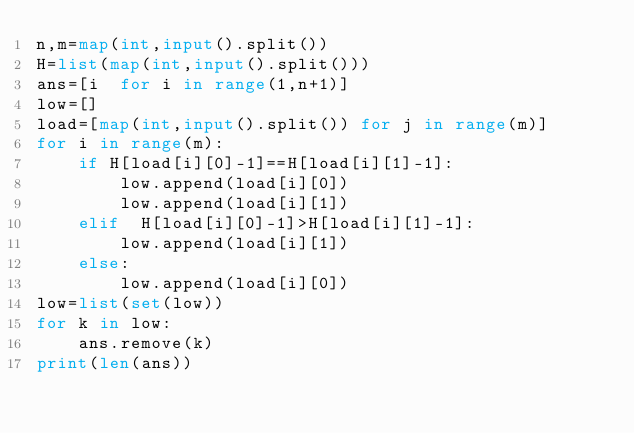<code> <loc_0><loc_0><loc_500><loc_500><_Python_>n,m=map(int,input().split())
H=list(map(int,input().split()))
ans=[i  for i in range(1,n+1)]
low=[]
load=[map(int,input().split()) for j in range(m)]
for i in range(m):
    if H[load[i][0]-1]==H[load[i][1]-1]:
        low.append(load[i][0])
        low.append(load[i][1])
    elif  H[load[i][0]-1]>H[load[i][1]-1]:
        low.append(load[i][1])
    else:
        low.append(load[i][0])
low=list(set(low))
for k in low:
    ans.remove(k)
print(len(ans))</code> 